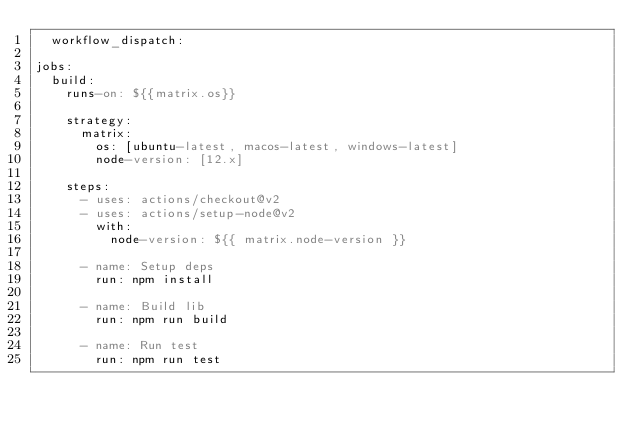Convert code to text. <code><loc_0><loc_0><loc_500><loc_500><_YAML_>  workflow_dispatch:

jobs:
  build:
    runs-on: ${{matrix.os}}

    strategy:
      matrix:
        os: [ubuntu-latest, macos-latest, windows-latest]
        node-version: [12.x]

    steps:
      - uses: actions/checkout@v2
      - uses: actions/setup-node@v2
        with:
          node-version: ${{ matrix.node-version }}

      - name: Setup deps
        run: npm install

      - name: Build lib
        run: npm run build

      - name: Run test
        run: npm run test
</code> 